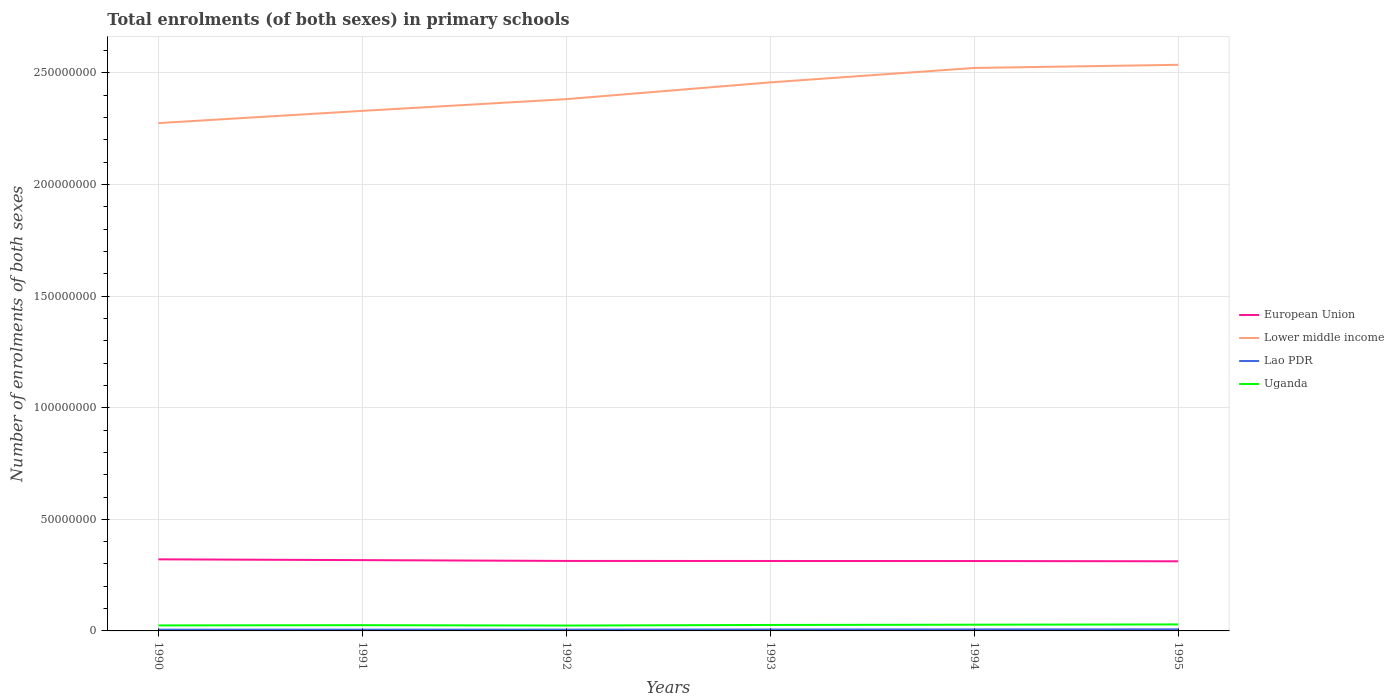Does the line corresponding to Lao PDR intersect with the line corresponding to European Union?
Your answer should be very brief. No. Is the number of lines equal to the number of legend labels?
Give a very brief answer. Yes. Across all years, what is the maximum number of enrolments in primary schools in Lower middle income?
Ensure brevity in your answer.  2.28e+08. In which year was the number of enrolments in primary schools in Lao PDR maximum?
Provide a succinct answer. 1990. What is the total number of enrolments in primary schools in Lao PDR in the graph?
Offer a terse response. -5.66e+04. What is the difference between the highest and the second highest number of enrolments in primary schools in European Union?
Your answer should be compact. 8.80e+05. Is the number of enrolments in primary schools in Lao PDR strictly greater than the number of enrolments in primary schools in European Union over the years?
Offer a terse response. Yes. How many lines are there?
Provide a succinct answer. 4. Are the values on the major ticks of Y-axis written in scientific E-notation?
Keep it short and to the point. No. Does the graph contain grids?
Ensure brevity in your answer.  Yes. Where does the legend appear in the graph?
Provide a succinct answer. Center right. How many legend labels are there?
Your answer should be very brief. 4. What is the title of the graph?
Ensure brevity in your answer.  Total enrolments (of both sexes) in primary schools. Does "Pakistan" appear as one of the legend labels in the graph?
Your answer should be compact. No. What is the label or title of the X-axis?
Provide a succinct answer. Years. What is the label or title of the Y-axis?
Provide a succinct answer. Number of enrolments of both sexes. What is the Number of enrolments of both sexes in European Union in 1990?
Provide a succinct answer. 3.21e+07. What is the Number of enrolments of both sexes of Lower middle income in 1990?
Ensure brevity in your answer.  2.28e+08. What is the Number of enrolments of both sexes of Lao PDR in 1990?
Keep it short and to the point. 5.64e+05. What is the Number of enrolments of both sexes of Uganda in 1990?
Your response must be concise. 2.47e+06. What is the Number of enrolments of both sexes in European Union in 1991?
Provide a short and direct response. 3.17e+07. What is the Number of enrolments of both sexes of Lower middle income in 1991?
Offer a very short reply. 2.33e+08. What is the Number of enrolments of both sexes in Lao PDR in 1991?
Your response must be concise. 5.76e+05. What is the Number of enrolments of both sexes of Uganda in 1991?
Provide a short and direct response. 2.58e+06. What is the Number of enrolments of both sexes of European Union in 1992?
Your answer should be very brief. 3.14e+07. What is the Number of enrolments of both sexes in Lower middle income in 1992?
Offer a terse response. 2.38e+08. What is the Number of enrolments of both sexes in Lao PDR in 1992?
Provide a short and direct response. 5.81e+05. What is the Number of enrolments of both sexes in Uganda in 1992?
Your answer should be compact. 2.40e+06. What is the Number of enrolments of both sexes of European Union in 1993?
Your response must be concise. 3.13e+07. What is the Number of enrolments of both sexes of Lower middle income in 1993?
Ensure brevity in your answer.  2.46e+08. What is the Number of enrolments of both sexes in Lao PDR in 1993?
Offer a terse response. 6.37e+05. What is the Number of enrolments of both sexes of Uganda in 1993?
Your answer should be compact. 2.67e+06. What is the Number of enrolments of both sexes of European Union in 1994?
Your answer should be compact. 3.13e+07. What is the Number of enrolments of both sexes in Lower middle income in 1994?
Offer a very short reply. 2.52e+08. What is the Number of enrolments of both sexes in Lao PDR in 1994?
Ensure brevity in your answer.  6.81e+05. What is the Number of enrolments of both sexes of Uganda in 1994?
Your answer should be compact. 2.79e+06. What is the Number of enrolments of both sexes of European Union in 1995?
Provide a succinct answer. 3.12e+07. What is the Number of enrolments of both sexes of Lower middle income in 1995?
Offer a terse response. 2.54e+08. What is the Number of enrolments of both sexes in Lao PDR in 1995?
Offer a very short reply. 7.11e+05. What is the Number of enrolments of both sexes of Uganda in 1995?
Provide a succinct answer. 2.91e+06. Across all years, what is the maximum Number of enrolments of both sexes of European Union?
Keep it short and to the point. 3.21e+07. Across all years, what is the maximum Number of enrolments of both sexes in Lower middle income?
Your response must be concise. 2.54e+08. Across all years, what is the maximum Number of enrolments of both sexes of Lao PDR?
Offer a very short reply. 7.11e+05. Across all years, what is the maximum Number of enrolments of both sexes of Uganda?
Your answer should be very brief. 2.91e+06. Across all years, what is the minimum Number of enrolments of both sexes of European Union?
Offer a very short reply. 3.12e+07. Across all years, what is the minimum Number of enrolments of both sexes in Lower middle income?
Ensure brevity in your answer.  2.28e+08. Across all years, what is the minimum Number of enrolments of both sexes in Lao PDR?
Give a very brief answer. 5.64e+05. Across all years, what is the minimum Number of enrolments of both sexes of Uganda?
Offer a very short reply. 2.40e+06. What is the total Number of enrolments of both sexes of European Union in the graph?
Your answer should be compact. 1.89e+08. What is the total Number of enrolments of both sexes of Lower middle income in the graph?
Make the answer very short. 1.45e+09. What is the total Number of enrolments of both sexes in Lao PDR in the graph?
Offer a very short reply. 3.75e+06. What is the total Number of enrolments of both sexes of Uganda in the graph?
Your answer should be compact. 1.58e+07. What is the difference between the Number of enrolments of both sexes of European Union in 1990 and that in 1991?
Offer a terse response. 3.55e+05. What is the difference between the Number of enrolments of both sexes in Lower middle income in 1990 and that in 1991?
Your response must be concise. -5.48e+06. What is the difference between the Number of enrolments of both sexes in Lao PDR in 1990 and that in 1991?
Provide a succinct answer. -1.27e+04. What is the difference between the Number of enrolments of both sexes in Uganda in 1990 and that in 1991?
Ensure brevity in your answer.  -1.07e+05. What is the difference between the Number of enrolments of both sexes of European Union in 1990 and that in 1992?
Provide a succinct answer. 7.25e+05. What is the difference between the Number of enrolments of both sexes of Lower middle income in 1990 and that in 1992?
Your response must be concise. -1.07e+07. What is the difference between the Number of enrolments of both sexes of Lao PDR in 1990 and that in 1992?
Your answer should be compact. -1.71e+04. What is the difference between the Number of enrolments of both sexes in Uganda in 1990 and that in 1992?
Make the answer very short. 6.62e+04. What is the difference between the Number of enrolments of both sexes of European Union in 1990 and that in 1993?
Provide a succinct answer. 7.43e+05. What is the difference between the Number of enrolments of both sexes in Lower middle income in 1990 and that in 1993?
Ensure brevity in your answer.  -1.82e+07. What is the difference between the Number of enrolments of both sexes of Lao PDR in 1990 and that in 1993?
Your answer should be compact. -7.36e+04. What is the difference between the Number of enrolments of both sexes in Uganda in 1990 and that in 1993?
Make the answer very short. -2.05e+05. What is the difference between the Number of enrolments of both sexes of European Union in 1990 and that in 1994?
Ensure brevity in your answer.  7.67e+05. What is the difference between the Number of enrolments of both sexes in Lower middle income in 1990 and that in 1994?
Keep it short and to the point. -2.47e+07. What is the difference between the Number of enrolments of both sexes of Lao PDR in 1990 and that in 1994?
Give a very brief answer. -1.17e+05. What is the difference between the Number of enrolments of both sexes in Uganda in 1990 and that in 1994?
Ensure brevity in your answer.  -3.20e+05. What is the difference between the Number of enrolments of both sexes in European Union in 1990 and that in 1995?
Your response must be concise. 8.80e+05. What is the difference between the Number of enrolments of both sexes of Lower middle income in 1990 and that in 1995?
Make the answer very short. -2.61e+07. What is the difference between the Number of enrolments of both sexes of Lao PDR in 1990 and that in 1995?
Your response must be concise. -1.47e+05. What is the difference between the Number of enrolments of both sexes in Uganda in 1990 and that in 1995?
Your response must be concise. -4.42e+05. What is the difference between the Number of enrolments of both sexes in European Union in 1991 and that in 1992?
Keep it short and to the point. 3.70e+05. What is the difference between the Number of enrolments of both sexes of Lower middle income in 1991 and that in 1992?
Provide a succinct answer. -5.25e+06. What is the difference between the Number of enrolments of both sexes in Lao PDR in 1991 and that in 1992?
Ensure brevity in your answer.  -4320. What is the difference between the Number of enrolments of both sexes in Uganda in 1991 and that in 1992?
Provide a succinct answer. 1.73e+05. What is the difference between the Number of enrolments of both sexes in European Union in 1991 and that in 1993?
Provide a succinct answer. 3.87e+05. What is the difference between the Number of enrolments of both sexes in Lower middle income in 1991 and that in 1993?
Offer a terse response. -1.28e+07. What is the difference between the Number of enrolments of both sexes of Lao PDR in 1991 and that in 1993?
Keep it short and to the point. -6.09e+04. What is the difference between the Number of enrolments of both sexes in Uganda in 1991 and that in 1993?
Provide a short and direct response. -9.84e+04. What is the difference between the Number of enrolments of both sexes in European Union in 1991 and that in 1994?
Provide a succinct answer. 4.11e+05. What is the difference between the Number of enrolments of both sexes of Lower middle income in 1991 and that in 1994?
Your answer should be very brief. -1.92e+07. What is the difference between the Number of enrolments of both sexes of Lao PDR in 1991 and that in 1994?
Your answer should be very brief. -1.05e+05. What is the difference between the Number of enrolments of both sexes in Uganda in 1991 and that in 1994?
Make the answer very short. -2.13e+05. What is the difference between the Number of enrolments of both sexes of European Union in 1991 and that in 1995?
Your response must be concise. 5.25e+05. What is the difference between the Number of enrolments of both sexes in Lower middle income in 1991 and that in 1995?
Keep it short and to the point. -2.06e+07. What is the difference between the Number of enrolments of both sexes in Lao PDR in 1991 and that in 1995?
Your response must be concise. -1.34e+05. What is the difference between the Number of enrolments of both sexes of Uganda in 1991 and that in 1995?
Provide a short and direct response. -3.36e+05. What is the difference between the Number of enrolments of both sexes in European Union in 1992 and that in 1993?
Ensure brevity in your answer.  1.76e+04. What is the difference between the Number of enrolments of both sexes in Lower middle income in 1992 and that in 1993?
Make the answer very short. -7.51e+06. What is the difference between the Number of enrolments of both sexes in Lao PDR in 1992 and that in 1993?
Your response must be concise. -5.66e+04. What is the difference between the Number of enrolments of both sexes of Uganda in 1992 and that in 1993?
Provide a succinct answer. -2.71e+05. What is the difference between the Number of enrolments of both sexes of European Union in 1992 and that in 1994?
Provide a succinct answer. 4.16e+04. What is the difference between the Number of enrolments of both sexes in Lower middle income in 1992 and that in 1994?
Provide a short and direct response. -1.40e+07. What is the difference between the Number of enrolments of both sexes of Lao PDR in 1992 and that in 1994?
Offer a very short reply. -1.00e+05. What is the difference between the Number of enrolments of both sexes in Uganda in 1992 and that in 1994?
Provide a succinct answer. -3.86e+05. What is the difference between the Number of enrolments of both sexes in European Union in 1992 and that in 1995?
Make the answer very short. 1.55e+05. What is the difference between the Number of enrolments of both sexes of Lower middle income in 1992 and that in 1995?
Your response must be concise. -1.54e+07. What is the difference between the Number of enrolments of both sexes in Lao PDR in 1992 and that in 1995?
Keep it short and to the point. -1.30e+05. What is the difference between the Number of enrolments of both sexes in Uganda in 1992 and that in 1995?
Make the answer very short. -5.09e+05. What is the difference between the Number of enrolments of both sexes in European Union in 1993 and that in 1994?
Offer a terse response. 2.40e+04. What is the difference between the Number of enrolments of both sexes in Lower middle income in 1993 and that in 1994?
Ensure brevity in your answer.  -6.46e+06. What is the difference between the Number of enrolments of both sexes of Lao PDR in 1993 and that in 1994?
Make the answer very short. -4.37e+04. What is the difference between the Number of enrolments of both sexes of Uganda in 1993 and that in 1994?
Your answer should be compact. -1.15e+05. What is the difference between the Number of enrolments of both sexes in European Union in 1993 and that in 1995?
Your response must be concise. 1.38e+05. What is the difference between the Number of enrolments of both sexes of Lower middle income in 1993 and that in 1995?
Your response must be concise. -7.87e+06. What is the difference between the Number of enrolments of both sexes in Lao PDR in 1993 and that in 1995?
Keep it short and to the point. -7.33e+04. What is the difference between the Number of enrolments of both sexes in Uganda in 1993 and that in 1995?
Give a very brief answer. -2.38e+05. What is the difference between the Number of enrolments of both sexes of European Union in 1994 and that in 1995?
Keep it short and to the point. 1.14e+05. What is the difference between the Number of enrolments of both sexes in Lower middle income in 1994 and that in 1995?
Ensure brevity in your answer.  -1.40e+06. What is the difference between the Number of enrolments of both sexes in Lao PDR in 1994 and that in 1995?
Give a very brief answer. -2.97e+04. What is the difference between the Number of enrolments of both sexes of Uganda in 1994 and that in 1995?
Your answer should be compact. -1.23e+05. What is the difference between the Number of enrolments of both sexes in European Union in 1990 and the Number of enrolments of both sexes in Lower middle income in 1991?
Your answer should be compact. -2.01e+08. What is the difference between the Number of enrolments of both sexes of European Union in 1990 and the Number of enrolments of both sexes of Lao PDR in 1991?
Keep it short and to the point. 3.15e+07. What is the difference between the Number of enrolments of both sexes of European Union in 1990 and the Number of enrolments of both sexes of Uganda in 1991?
Offer a very short reply. 2.95e+07. What is the difference between the Number of enrolments of both sexes in Lower middle income in 1990 and the Number of enrolments of both sexes in Lao PDR in 1991?
Your response must be concise. 2.27e+08. What is the difference between the Number of enrolments of both sexes of Lower middle income in 1990 and the Number of enrolments of both sexes of Uganda in 1991?
Make the answer very short. 2.25e+08. What is the difference between the Number of enrolments of both sexes in Lao PDR in 1990 and the Number of enrolments of both sexes in Uganda in 1991?
Give a very brief answer. -2.01e+06. What is the difference between the Number of enrolments of both sexes of European Union in 1990 and the Number of enrolments of both sexes of Lower middle income in 1992?
Provide a succinct answer. -2.06e+08. What is the difference between the Number of enrolments of both sexes of European Union in 1990 and the Number of enrolments of both sexes of Lao PDR in 1992?
Your answer should be compact. 3.15e+07. What is the difference between the Number of enrolments of both sexes in European Union in 1990 and the Number of enrolments of both sexes in Uganda in 1992?
Your answer should be compact. 2.97e+07. What is the difference between the Number of enrolments of both sexes of Lower middle income in 1990 and the Number of enrolments of both sexes of Lao PDR in 1992?
Give a very brief answer. 2.27e+08. What is the difference between the Number of enrolments of both sexes of Lower middle income in 1990 and the Number of enrolments of both sexes of Uganda in 1992?
Keep it short and to the point. 2.25e+08. What is the difference between the Number of enrolments of both sexes of Lao PDR in 1990 and the Number of enrolments of both sexes of Uganda in 1992?
Provide a succinct answer. -1.84e+06. What is the difference between the Number of enrolments of both sexes in European Union in 1990 and the Number of enrolments of both sexes in Lower middle income in 1993?
Provide a short and direct response. -2.14e+08. What is the difference between the Number of enrolments of both sexes of European Union in 1990 and the Number of enrolments of both sexes of Lao PDR in 1993?
Offer a very short reply. 3.14e+07. What is the difference between the Number of enrolments of both sexes of European Union in 1990 and the Number of enrolments of both sexes of Uganda in 1993?
Ensure brevity in your answer.  2.94e+07. What is the difference between the Number of enrolments of both sexes of Lower middle income in 1990 and the Number of enrolments of both sexes of Lao PDR in 1993?
Provide a succinct answer. 2.27e+08. What is the difference between the Number of enrolments of both sexes in Lower middle income in 1990 and the Number of enrolments of both sexes in Uganda in 1993?
Give a very brief answer. 2.25e+08. What is the difference between the Number of enrolments of both sexes of Lao PDR in 1990 and the Number of enrolments of both sexes of Uganda in 1993?
Your answer should be compact. -2.11e+06. What is the difference between the Number of enrolments of both sexes in European Union in 1990 and the Number of enrolments of both sexes in Lower middle income in 1994?
Provide a succinct answer. -2.20e+08. What is the difference between the Number of enrolments of both sexes in European Union in 1990 and the Number of enrolments of both sexes in Lao PDR in 1994?
Provide a short and direct response. 3.14e+07. What is the difference between the Number of enrolments of both sexes of European Union in 1990 and the Number of enrolments of both sexes of Uganda in 1994?
Ensure brevity in your answer.  2.93e+07. What is the difference between the Number of enrolments of both sexes of Lower middle income in 1990 and the Number of enrolments of both sexes of Lao PDR in 1994?
Provide a short and direct response. 2.27e+08. What is the difference between the Number of enrolments of both sexes of Lower middle income in 1990 and the Number of enrolments of both sexes of Uganda in 1994?
Make the answer very short. 2.25e+08. What is the difference between the Number of enrolments of both sexes in Lao PDR in 1990 and the Number of enrolments of both sexes in Uganda in 1994?
Provide a succinct answer. -2.23e+06. What is the difference between the Number of enrolments of both sexes of European Union in 1990 and the Number of enrolments of both sexes of Lower middle income in 1995?
Provide a short and direct response. -2.22e+08. What is the difference between the Number of enrolments of both sexes in European Union in 1990 and the Number of enrolments of both sexes in Lao PDR in 1995?
Your response must be concise. 3.14e+07. What is the difference between the Number of enrolments of both sexes of European Union in 1990 and the Number of enrolments of both sexes of Uganda in 1995?
Provide a succinct answer. 2.92e+07. What is the difference between the Number of enrolments of both sexes in Lower middle income in 1990 and the Number of enrolments of both sexes in Lao PDR in 1995?
Provide a short and direct response. 2.27e+08. What is the difference between the Number of enrolments of both sexes in Lower middle income in 1990 and the Number of enrolments of both sexes in Uganda in 1995?
Keep it short and to the point. 2.25e+08. What is the difference between the Number of enrolments of both sexes in Lao PDR in 1990 and the Number of enrolments of both sexes in Uganda in 1995?
Offer a very short reply. -2.35e+06. What is the difference between the Number of enrolments of both sexes in European Union in 1991 and the Number of enrolments of both sexes in Lower middle income in 1992?
Give a very brief answer. -2.07e+08. What is the difference between the Number of enrolments of both sexes of European Union in 1991 and the Number of enrolments of both sexes of Lao PDR in 1992?
Offer a terse response. 3.11e+07. What is the difference between the Number of enrolments of both sexes of European Union in 1991 and the Number of enrolments of both sexes of Uganda in 1992?
Ensure brevity in your answer.  2.93e+07. What is the difference between the Number of enrolments of both sexes in Lower middle income in 1991 and the Number of enrolments of both sexes in Lao PDR in 1992?
Offer a very short reply. 2.32e+08. What is the difference between the Number of enrolments of both sexes in Lower middle income in 1991 and the Number of enrolments of both sexes in Uganda in 1992?
Your answer should be very brief. 2.31e+08. What is the difference between the Number of enrolments of both sexes in Lao PDR in 1991 and the Number of enrolments of both sexes in Uganda in 1992?
Give a very brief answer. -1.83e+06. What is the difference between the Number of enrolments of both sexes of European Union in 1991 and the Number of enrolments of both sexes of Lower middle income in 1993?
Offer a terse response. -2.14e+08. What is the difference between the Number of enrolments of both sexes in European Union in 1991 and the Number of enrolments of both sexes in Lao PDR in 1993?
Provide a succinct answer. 3.11e+07. What is the difference between the Number of enrolments of both sexes of European Union in 1991 and the Number of enrolments of both sexes of Uganda in 1993?
Give a very brief answer. 2.90e+07. What is the difference between the Number of enrolments of both sexes of Lower middle income in 1991 and the Number of enrolments of both sexes of Lao PDR in 1993?
Provide a short and direct response. 2.32e+08. What is the difference between the Number of enrolments of both sexes in Lower middle income in 1991 and the Number of enrolments of both sexes in Uganda in 1993?
Your response must be concise. 2.30e+08. What is the difference between the Number of enrolments of both sexes in Lao PDR in 1991 and the Number of enrolments of both sexes in Uganda in 1993?
Keep it short and to the point. -2.10e+06. What is the difference between the Number of enrolments of both sexes of European Union in 1991 and the Number of enrolments of both sexes of Lower middle income in 1994?
Your response must be concise. -2.21e+08. What is the difference between the Number of enrolments of both sexes of European Union in 1991 and the Number of enrolments of both sexes of Lao PDR in 1994?
Your response must be concise. 3.10e+07. What is the difference between the Number of enrolments of both sexes in European Union in 1991 and the Number of enrolments of both sexes in Uganda in 1994?
Provide a succinct answer. 2.89e+07. What is the difference between the Number of enrolments of both sexes of Lower middle income in 1991 and the Number of enrolments of both sexes of Lao PDR in 1994?
Your response must be concise. 2.32e+08. What is the difference between the Number of enrolments of both sexes in Lower middle income in 1991 and the Number of enrolments of both sexes in Uganda in 1994?
Offer a very short reply. 2.30e+08. What is the difference between the Number of enrolments of both sexes in Lao PDR in 1991 and the Number of enrolments of both sexes in Uganda in 1994?
Your response must be concise. -2.21e+06. What is the difference between the Number of enrolments of both sexes of European Union in 1991 and the Number of enrolments of both sexes of Lower middle income in 1995?
Offer a terse response. -2.22e+08. What is the difference between the Number of enrolments of both sexes in European Union in 1991 and the Number of enrolments of both sexes in Lao PDR in 1995?
Your response must be concise. 3.10e+07. What is the difference between the Number of enrolments of both sexes of European Union in 1991 and the Number of enrolments of both sexes of Uganda in 1995?
Give a very brief answer. 2.88e+07. What is the difference between the Number of enrolments of both sexes in Lower middle income in 1991 and the Number of enrolments of both sexes in Lao PDR in 1995?
Offer a very short reply. 2.32e+08. What is the difference between the Number of enrolments of both sexes of Lower middle income in 1991 and the Number of enrolments of both sexes of Uganda in 1995?
Make the answer very short. 2.30e+08. What is the difference between the Number of enrolments of both sexes of Lao PDR in 1991 and the Number of enrolments of both sexes of Uganda in 1995?
Your response must be concise. -2.34e+06. What is the difference between the Number of enrolments of both sexes in European Union in 1992 and the Number of enrolments of both sexes in Lower middle income in 1993?
Offer a terse response. -2.14e+08. What is the difference between the Number of enrolments of both sexes of European Union in 1992 and the Number of enrolments of both sexes of Lao PDR in 1993?
Offer a terse response. 3.07e+07. What is the difference between the Number of enrolments of both sexes in European Union in 1992 and the Number of enrolments of both sexes in Uganda in 1993?
Ensure brevity in your answer.  2.87e+07. What is the difference between the Number of enrolments of both sexes in Lower middle income in 1992 and the Number of enrolments of both sexes in Lao PDR in 1993?
Your response must be concise. 2.38e+08. What is the difference between the Number of enrolments of both sexes in Lower middle income in 1992 and the Number of enrolments of both sexes in Uganda in 1993?
Provide a short and direct response. 2.36e+08. What is the difference between the Number of enrolments of both sexes in Lao PDR in 1992 and the Number of enrolments of both sexes in Uganda in 1993?
Provide a succinct answer. -2.09e+06. What is the difference between the Number of enrolments of both sexes in European Union in 1992 and the Number of enrolments of both sexes in Lower middle income in 1994?
Ensure brevity in your answer.  -2.21e+08. What is the difference between the Number of enrolments of both sexes of European Union in 1992 and the Number of enrolments of both sexes of Lao PDR in 1994?
Give a very brief answer. 3.07e+07. What is the difference between the Number of enrolments of both sexes in European Union in 1992 and the Number of enrolments of both sexes in Uganda in 1994?
Provide a short and direct response. 2.86e+07. What is the difference between the Number of enrolments of both sexes in Lower middle income in 1992 and the Number of enrolments of both sexes in Lao PDR in 1994?
Give a very brief answer. 2.38e+08. What is the difference between the Number of enrolments of both sexes in Lower middle income in 1992 and the Number of enrolments of both sexes in Uganda in 1994?
Ensure brevity in your answer.  2.35e+08. What is the difference between the Number of enrolments of both sexes in Lao PDR in 1992 and the Number of enrolments of both sexes in Uganda in 1994?
Give a very brief answer. -2.21e+06. What is the difference between the Number of enrolments of both sexes of European Union in 1992 and the Number of enrolments of both sexes of Lower middle income in 1995?
Your answer should be compact. -2.22e+08. What is the difference between the Number of enrolments of both sexes in European Union in 1992 and the Number of enrolments of both sexes in Lao PDR in 1995?
Make the answer very short. 3.06e+07. What is the difference between the Number of enrolments of both sexes in European Union in 1992 and the Number of enrolments of both sexes in Uganda in 1995?
Make the answer very short. 2.84e+07. What is the difference between the Number of enrolments of both sexes of Lower middle income in 1992 and the Number of enrolments of both sexes of Lao PDR in 1995?
Make the answer very short. 2.38e+08. What is the difference between the Number of enrolments of both sexes of Lower middle income in 1992 and the Number of enrolments of both sexes of Uganda in 1995?
Your answer should be very brief. 2.35e+08. What is the difference between the Number of enrolments of both sexes of Lao PDR in 1992 and the Number of enrolments of both sexes of Uganda in 1995?
Give a very brief answer. -2.33e+06. What is the difference between the Number of enrolments of both sexes in European Union in 1993 and the Number of enrolments of both sexes in Lower middle income in 1994?
Ensure brevity in your answer.  -2.21e+08. What is the difference between the Number of enrolments of both sexes in European Union in 1993 and the Number of enrolments of both sexes in Lao PDR in 1994?
Your response must be concise. 3.07e+07. What is the difference between the Number of enrolments of both sexes in European Union in 1993 and the Number of enrolments of both sexes in Uganda in 1994?
Give a very brief answer. 2.85e+07. What is the difference between the Number of enrolments of both sexes in Lower middle income in 1993 and the Number of enrolments of both sexes in Lao PDR in 1994?
Give a very brief answer. 2.45e+08. What is the difference between the Number of enrolments of both sexes in Lower middle income in 1993 and the Number of enrolments of both sexes in Uganda in 1994?
Keep it short and to the point. 2.43e+08. What is the difference between the Number of enrolments of both sexes of Lao PDR in 1993 and the Number of enrolments of both sexes of Uganda in 1994?
Offer a terse response. -2.15e+06. What is the difference between the Number of enrolments of both sexes in European Union in 1993 and the Number of enrolments of both sexes in Lower middle income in 1995?
Ensure brevity in your answer.  -2.22e+08. What is the difference between the Number of enrolments of both sexes of European Union in 1993 and the Number of enrolments of both sexes of Lao PDR in 1995?
Your answer should be compact. 3.06e+07. What is the difference between the Number of enrolments of both sexes of European Union in 1993 and the Number of enrolments of both sexes of Uganda in 1995?
Provide a short and direct response. 2.84e+07. What is the difference between the Number of enrolments of both sexes of Lower middle income in 1993 and the Number of enrolments of both sexes of Lao PDR in 1995?
Offer a very short reply. 2.45e+08. What is the difference between the Number of enrolments of both sexes in Lower middle income in 1993 and the Number of enrolments of both sexes in Uganda in 1995?
Offer a terse response. 2.43e+08. What is the difference between the Number of enrolments of both sexes in Lao PDR in 1993 and the Number of enrolments of both sexes in Uganda in 1995?
Offer a terse response. -2.28e+06. What is the difference between the Number of enrolments of both sexes of European Union in 1994 and the Number of enrolments of both sexes of Lower middle income in 1995?
Ensure brevity in your answer.  -2.22e+08. What is the difference between the Number of enrolments of both sexes in European Union in 1994 and the Number of enrolments of both sexes in Lao PDR in 1995?
Your answer should be compact. 3.06e+07. What is the difference between the Number of enrolments of both sexes of European Union in 1994 and the Number of enrolments of both sexes of Uganda in 1995?
Offer a very short reply. 2.84e+07. What is the difference between the Number of enrolments of both sexes in Lower middle income in 1994 and the Number of enrolments of both sexes in Lao PDR in 1995?
Your answer should be compact. 2.52e+08. What is the difference between the Number of enrolments of both sexes in Lower middle income in 1994 and the Number of enrolments of both sexes in Uganda in 1995?
Keep it short and to the point. 2.49e+08. What is the difference between the Number of enrolments of both sexes in Lao PDR in 1994 and the Number of enrolments of both sexes in Uganda in 1995?
Make the answer very short. -2.23e+06. What is the average Number of enrolments of both sexes of European Union per year?
Your response must be concise. 3.15e+07. What is the average Number of enrolments of both sexes in Lower middle income per year?
Ensure brevity in your answer.  2.42e+08. What is the average Number of enrolments of both sexes in Lao PDR per year?
Provide a succinct answer. 6.25e+05. What is the average Number of enrolments of both sexes in Uganda per year?
Offer a terse response. 2.64e+06. In the year 1990, what is the difference between the Number of enrolments of both sexes in European Union and Number of enrolments of both sexes in Lower middle income?
Give a very brief answer. -1.95e+08. In the year 1990, what is the difference between the Number of enrolments of both sexes in European Union and Number of enrolments of both sexes in Lao PDR?
Offer a very short reply. 3.15e+07. In the year 1990, what is the difference between the Number of enrolments of both sexes of European Union and Number of enrolments of both sexes of Uganda?
Your response must be concise. 2.96e+07. In the year 1990, what is the difference between the Number of enrolments of both sexes of Lower middle income and Number of enrolments of both sexes of Lao PDR?
Offer a very short reply. 2.27e+08. In the year 1990, what is the difference between the Number of enrolments of both sexes in Lower middle income and Number of enrolments of both sexes in Uganda?
Keep it short and to the point. 2.25e+08. In the year 1990, what is the difference between the Number of enrolments of both sexes of Lao PDR and Number of enrolments of both sexes of Uganda?
Your response must be concise. -1.91e+06. In the year 1991, what is the difference between the Number of enrolments of both sexes of European Union and Number of enrolments of both sexes of Lower middle income?
Make the answer very short. -2.01e+08. In the year 1991, what is the difference between the Number of enrolments of both sexes in European Union and Number of enrolments of both sexes in Lao PDR?
Provide a succinct answer. 3.11e+07. In the year 1991, what is the difference between the Number of enrolments of both sexes in European Union and Number of enrolments of both sexes in Uganda?
Offer a terse response. 2.91e+07. In the year 1991, what is the difference between the Number of enrolments of both sexes in Lower middle income and Number of enrolments of both sexes in Lao PDR?
Provide a succinct answer. 2.32e+08. In the year 1991, what is the difference between the Number of enrolments of both sexes of Lower middle income and Number of enrolments of both sexes of Uganda?
Give a very brief answer. 2.30e+08. In the year 1991, what is the difference between the Number of enrolments of both sexes of Lao PDR and Number of enrolments of both sexes of Uganda?
Keep it short and to the point. -2.00e+06. In the year 1992, what is the difference between the Number of enrolments of both sexes in European Union and Number of enrolments of both sexes in Lower middle income?
Give a very brief answer. -2.07e+08. In the year 1992, what is the difference between the Number of enrolments of both sexes of European Union and Number of enrolments of both sexes of Lao PDR?
Give a very brief answer. 3.08e+07. In the year 1992, what is the difference between the Number of enrolments of both sexes in European Union and Number of enrolments of both sexes in Uganda?
Give a very brief answer. 2.89e+07. In the year 1992, what is the difference between the Number of enrolments of both sexes in Lower middle income and Number of enrolments of both sexes in Lao PDR?
Ensure brevity in your answer.  2.38e+08. In the year 1992, what is the difference between the Number of enrolments of both sexes in Lower middle income and Number of enrolments of both sexes in Uganda?
Your answer should be compact. 2.36e+08. In the year 1992, what is the difference between the Number of enrolments of both sexes of Lao PDR and Number of enrolments of both sexes of Uganda?
Offer a terse response. -1.82e+06. In the year 1993, what is the difference between the Number of enrolments of both sexes of European Union and Number of enrolments of both sexes of Lower middle income?
Ensure brevity in your answer.  -2.14e+08. In the year 1993, what is the difference between the Number of enrolments of both sexes in European Union and Number of enrolments of both sexes in Lao PDR?
Your answer should be very brief. 3.07e+07. In the year 1993, what is the difference between the Number of enrolments of both sexes in European Union and Number of enrolments of both sexes in Uganda?
Your answer should be compact. 2.87e+07. In the year 1993, what is the difference between the Number of enrolments of both sexes in Lower middle income and Number of enrolments of both sexes in Lao PDR?
Your answer should be compact. 2.45e+08. In the year 1993, what is the difference between the Number of enrolments of both sexes of Lower middle income and Number of enrolments of both sexes of Uganda?
Offer a very short reply. 2.43e+08. In the year 1993, what is the difference between the Number of enrolments of both sexes of Lao PDR and Number of enrolments of both sexes of Uganda?
Your answer should be compact. -2.04e+06. In the year 1994, what is the difference between the Number of enrolments of both sexes in European Union and Number of enrolments of both sexes in Lower middle income?
Your response must be concise. -2.21e+08. In the year 1994, what is the difference between the Number of enrolments of both sexes in European Union and Number of enrolments of both sexes in Lao PDR?
Give a very brief answer. 3.06e+07. In the year 1994, what is the difference between the Number of enrolments of both sexes of European Union and Number of enrolments of both sexes of Uganda?
Your response must be concise. 2.85e+07. In the year 1994, what is the difference between the Number of enrolments of both sexes in Lower middle income and Number of enrolments of both sexes in Lao PDR?
Provide a short and direct response. 2.52e+08. In the year 1994, what is the difference between the Number of enrolments of both sexes in Lower middle income and Number of enrolments of both sexes in Uganda?
Your answer should be compact. 2.49e+08. In the year 1994, what is the difference between the Number of enrolments of both sexes in Lao PDR and Number of enrolments of both sexes in Uganda?
Your answer should be compact. -2.11e+06. In the year 1995, what is the difference between the Number of enrolments of both sexes in European Union and Number of enrolments of both sexes in Lower middle income?
Your answer should be very brief. -2.22e+08. In the year 1995, what is the difference between the Number of enrolments of both sexes in European Union and Number of enrolments of both sexes in Lao PDR?
Your response must be concise. 3.05e+07. In the year 1995, what is the difference between the Number of enrolments of both sexes of European Union and Number of enrolments of both sexes of Uganda?
Your answer should be compact. 2.83e+07. In the year 1995, what is the difference between the Number of enrolments of both sexes in Lower middle income and Number of enrolments of both sexes in Lao PDR?
Ensure brevity in your answer.  2.53e+08. In the year 1995, what is the difference between the Number of enrolments of both sexes in Lower middle income and Number of enrolments of both sexes in Uganda?
Make the answer very short. 2.51e+08. In the year 1995, what is the difference between the Number of enrolments of both sexes of Lao PDR and Number of enrolments of both sexes of Uganda?
Offer a terse response. -2.20e+06. What is the ratio of the Number of enrolments of both sexes in European Union in 1990 to that in 1991?
Offer a terse response. 1.01. What is the ratio of the Number of enrolments of both sexes of Lower middle income in 1990 to that in 1991?
Your answer should be compact. 0.98. What is the ratio of the Number of enrolments of both sexes in Lao PDR in 1990 to that in 1991?
Offer a terse response. 0.98. What is the ratio of the Number of enrolments of both sexes of Uganda in 1990 to that in 1991?
Provide a short and direct response. 0.96. What is the ratio of the Number of enrolments of both sexes in European Union in 1990 to that in 1992?
Your answer should be very brief. 1.02. What is the ratio of the Number of enrolments of both sexes in Lower middle income in 1990 to that in 1992?
Your answer should be very brief. 0.95. What is the ratio of the Number of enrolments of both sexes in Lao PDR in 1990 to that in 1992?
Make the answer very short. 0.97. What is the ratio of the Number of enrolments of both sexes of Uganda in 1990 to that in 1992?
Offer a very short reply. 1.03. What is the ratio of the Number of enrolments of both sexes in European Union in 1990 to that in 1993?
Give a very brief answer. 1.02. What is the ratio of the Number of enrolments of both sexes of Lower middle income in 1990 to that in 1993?
Ensure brevity in your answer.  0.93. What is the ratio of the Number of enrolments of both sexes in Lao PDR in 1990 to that in 1993?
Ensure brevity in your answer.  0.88. What is the ratio of the Number of enrolments of both sexes of Uganda in 1990 to that in 1993?
Keep it short and to the point. 0.92. What is the ratio of the Number of enrolments of both sexes of European Union in 1990 to that in 1994?
Offer a very short reply. 1.02. What is the ratio of the Number of enrolments of both sexes of Lower middle income in 1990 to that in 1994?
Your answer should be very brief. 0.9. What is the ratio of the Number of enrolments of both sexes in Lao PDR in 1990 to that in 1994?
Your response must be concise. 0.83. What is the ratio of the Number of enrolments of both sexes in Uganda in 1990 to that in 1994?
Your answer should be very brief. 0.89. What is the ratio of the Number of enrolments of both sexes in European Union in 1990 to that in 1995?
Your answer should be very brief. 1.03. What is the ratio of the Number of enrolments of both sexes in Lower middle income in 1990 to that in 1995?
Your answer should be compact. 0.9. What is the ratio of the Number of enrolments of both sexes of Lao PDR in 1990 to that in 1995?
Your response must be concise. 0.79. What is the ratio of the Number of enrolments of both sexes of Uganda in 1990 to that in 1995?
Give a very brief answer. 0.85. What is the ratio of the Number of enrolments of both sexes in European Union in 1991 to that in 1992?
Offer a terse response. 1.01. What is the ratio of the Number of enrolments of both sexes of Lower middle income in 1991 to that in 1992?
Make the answer very short. 0.98. What is the ratio of the Number of enrolments of both sexes in Lao PDR in 1991 to that in 1992?
Keep it short and to the point. 0.99. What is the ratio of the Number of enrolments of both sexes in Uganda in 1991 to that in 1992?
Give a very brief answer. 1.07. What is the ratio of the Number of enrolments of both sexes of European Union in 1991 to that in 1993?
Offer a very short reply. 1.01. What is the ratio of the Number of enrolments of both sexes in Lower middle income in 1991 to that in 1993?
Your answer should be very brief. 0.95. What is the ratio of the Number of enrolments of both sexes of Lao PDR in 1991 to that in 1993?
Your response must be concise. 0.9. What is the ratio of the Number of enrolments of both sexes of Uganda in 1991 to that in 1993?
Provide a short and direct response. 0.96. What is the ratio of the Number of enrolments of both sexes of European Union in 1991 to that in 1994?
Provide a short and direct response. 1.01. What is the ratio of the Number of enrolments of both sexes of Lower middle income in 1991 to that in 1994?
Offer a very short reply. 0.92. What is the ratio of the Number of enrolments of both sexes in Lao PDR in 1991 to that in 1994?
Keep it short and to the point. 0.85. What is the ratio of the Number of enrolments of both sexes in Uganda in 1991 to that in 1994?
Keep it short and to the point. 0.92. What is the ratio of the Number of enrolments of both sexes of European Union in 1991 to that in 1995?
Offer a very short reply. 1.02. What is the ratio of the Number of enrolments of both sexes of Lower middle income in 1991 to that in 1995?
Make the answer very short. 0.92. What is the ratio of the Number of enrolments of both sexes of Lao PDR in 1991 to that in 1995?
Your answer should be compact. 0.81. What is the ratio of the Number of enrolments of both sexes in Uganda in 1991 to that in 1995?
Offer a very short reply. 0.88. What is the ratio of the Number of enrolments of both sexes in Lower middle income in 1992 to that in 1993?
Ensure brevity in your answer.  0.97. What is the ratio of the Number of enrolments of both sexes in Lao PDR in 1992 to that in 1993?
Provide a succinct answer. 0.91. What is the ratio of the Number of enrolments of both sexes in Uganda in 1992 to that in 1993?
Offer a very short reply. 0.9. What is the ratio of the Number of enrolments of both sexes in Lower middle income in 1992 to that in 1994?
Offer a very short reply. 0.94. What is the ratio of the Number of enrolments of both sexes in Lao PDR in 1992 to that in 1994?
Provide a short and direct response. 0.85. What is the ratio of the Number of enrolments of both sexes in Uganda in 1992 to that in 1994?
Ensure brevity in your answer.  0.86. What is the ratio of the Number of enrolments of both sexes of European Union in 1992 to that in 1995?
Provide a short and direct response. 1. What is the ratio of the Number of enrolments of both sexes in Lower middle income in 1992 to that in 1995?
Your answer should be compact. 0.94. What is the ratio of the Number of enrolments of both sexes of Lao PDR in 1992 to that in 1995?
Your answer should be compact. 0.82. What is the ratio of the Number of enrolments of both sexes of Uganda in 1992 to that in 1995?
Make the answer very short. 0.83. What is the ratio of the Number of enrolments of both sexes in Lower middle income in 1993 to that in 1994?
Provide a short and direct response. 0.97. What is the ratio of the Number of enrolments of both sexes in Lao PDR in 1993 to that in 1994?
Your answer should be very brief. 0.94. What is the ratio of the Number of enrolments of both sexes in Uganda in 1993 to that in 1994?
Make the answer very short. 0.96. What is the ratio of the Number of enrolments of both sexes in Lao PDR in 1993 to that in 1995?
Provide a succinct answer. 0.9. What is the ratio of the Number of enrolments of both sexes of Uganda in 1993 to that in 1995?
Offer a very short reply. 0.92. What is the ratio of the Number of enrolments of both sexes of European Union in 1994 to that in 1995?
Offer a very short reply. 1. What is the ratio of the Number of enrolments of both sexes in Lao PDR in 1994 to that in 1995?
Offer a very short reply. 0.96. What is the ratio of the Number of enrolments of both sexes of Uganda in 1994 to that in 1995?
Your answer should be compact. 0.96. What is the difference between the highest and the second highest Number of enrolments of both sexes in European Union?
Offer a very short reply. 3.55e+05. What is the difference between the highest and the second highest Number of enrolments of both sexes in Lower middle income?
Give a very brief answer. 1.40e+06. What is the difference between the highest and the second highest Number of enrolments of both sexes of Lao PDR?
Provide a succinct answer. 2.97e+04. What is the difference between the highest and the second highest Number of enrolments of both sexes of Uganda?
Provide a short and direct response. 1.23e+05. What is the difference between the highest and the lowest Number of enrolments of both sexes of European Union?
Provide a short and direct response. 8.80e+05. What is the difference between the highest and the lowest Number of enrolments of both sexes of Lower middle income?
Ensure brevity in your answer.  2.61e+07. What is the difference between the highest and the lowest Number of enrolments of both sexes in Lao PDR?
Provide a short and direct response. 1.47e+05. What is the difference between the highest and the lowest Number of enrolments of both sexes of Uganda?
Provide a succinct answer. 5.09e+05. 